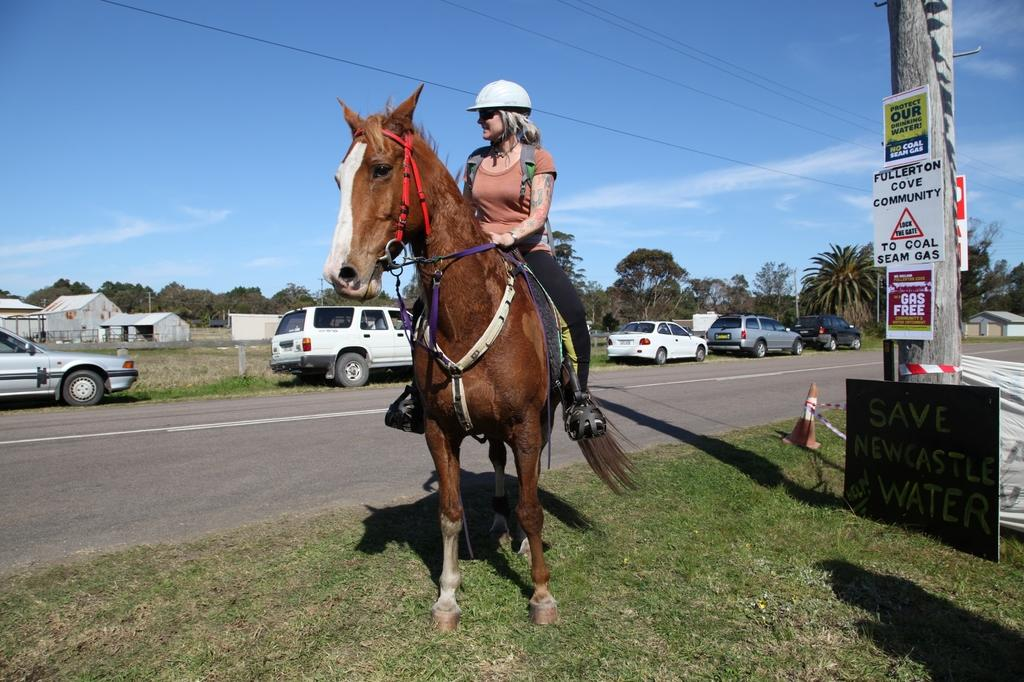Who is the main subject in the image? There is a woman in the image. What is the woman doing in the image? The woman is sitting on a horse. Where is the horse standing in the image? The horse is standing on the road. What else can be seen on the road in the image? Cars are parked on the road. What type of skirt is the woman wearing in the image? There is no information about the woman's clothing in the image, so we cannot determine if she is wearing a skirt or not. 